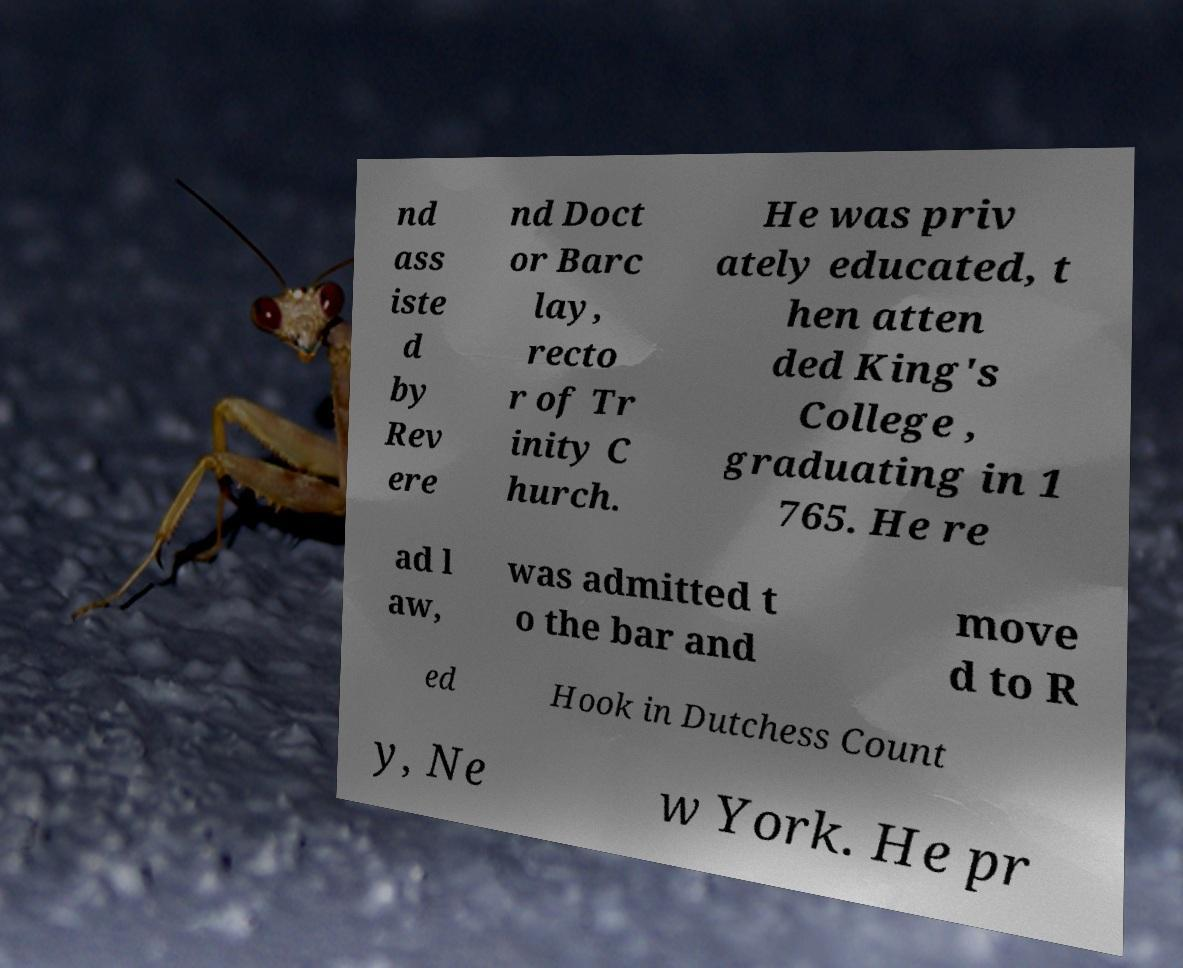Can you accurately transcribe the text from the provided image for me? nd ass iste d by Rev ere nd Doct or Barc lay, recto r of Tr inity C hurch. He was priv ately educated, t hen atten ded King's College , graduating in 1 765. He re ad l aw, was admitted t o the bar and move d to R ed Hook in Dutchess Count y, Ne w York. He pr 